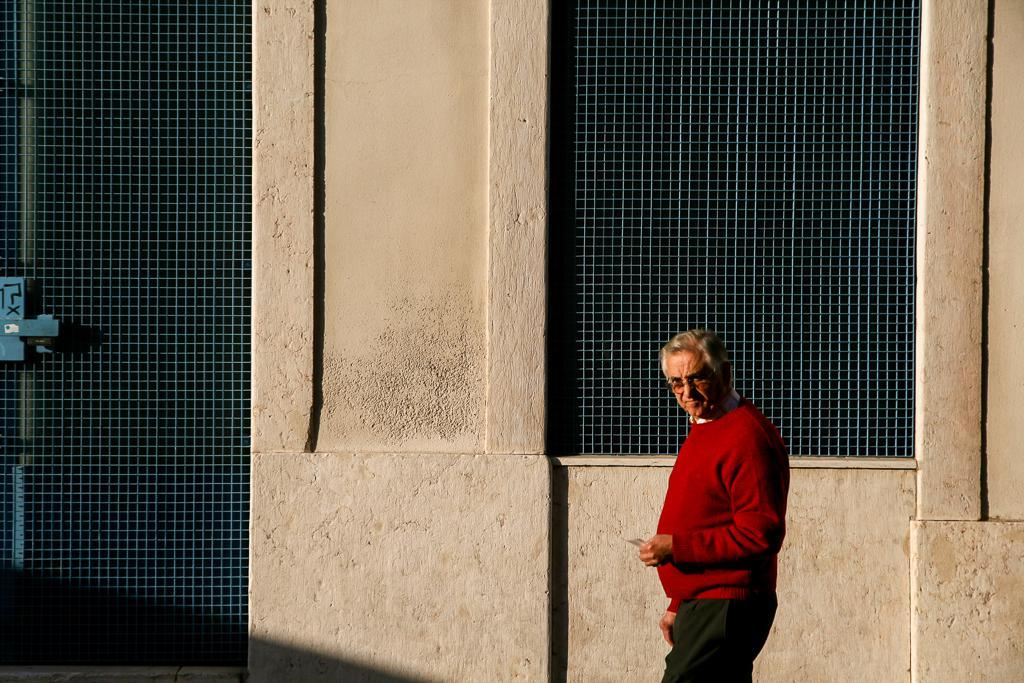Who is present in the image? There is a man in the image. What is the man wearing on his upper body? The man is wearing a red shirt. What is the man wearing on his lower body? The man is wearing black pants. What can be seen behind the man? There is a wall behind the man. What architectural feature is visible in the image? There is a window in the image. What type of vein can be seen on the man's arm in the image? There is no visible vein on the man's arm in the image. What color is the dress the man is wearing in the image? The man is not wearing a dress in the image; he is wearing a red shirt and black pants. 